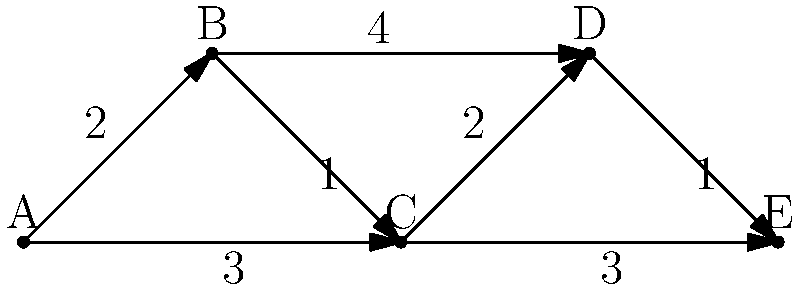Given the network graph representing ancient trade routes between cities A, B, C, D, and E, with edge weights indicating the strength of trade connections, what is the total strength of the most efficient trade route from city A to city E? To find the most efficient trade route from city A to city E, we need to analyze all possible paths and calculate their total strengths. The path with the highest total strength will be the most efficient route.

Step 1: Identify all possible paths from A to E:
1. A → B → C → E
2. A → B → D → E
3. A → C → D → E
4. A → C → E

Step 2: Calculate the total strength for each path:
1. A → B → C → E: 2 + 1 + 3 = 6
2. A → B → D → E: 2 + 4 + 1 = 7
3. A → C → D → E: 3 + 2 + 1 = 6
4. A → C → E: 3 + 3 = 6

Step 3: Identify the path with the highest total strength:
The path with the highest total strength is A → B → D → E, with a total strength of 7.

This analysis demonstrates how network theory can be applied to archaeological data to understand ancient trade patterns. By quantifying the strength of connections between cities, we can identify the most likely routes for goods and cultural exchange, providing insights into the economic and social structures of ancient civilizations.
Answer: 7 